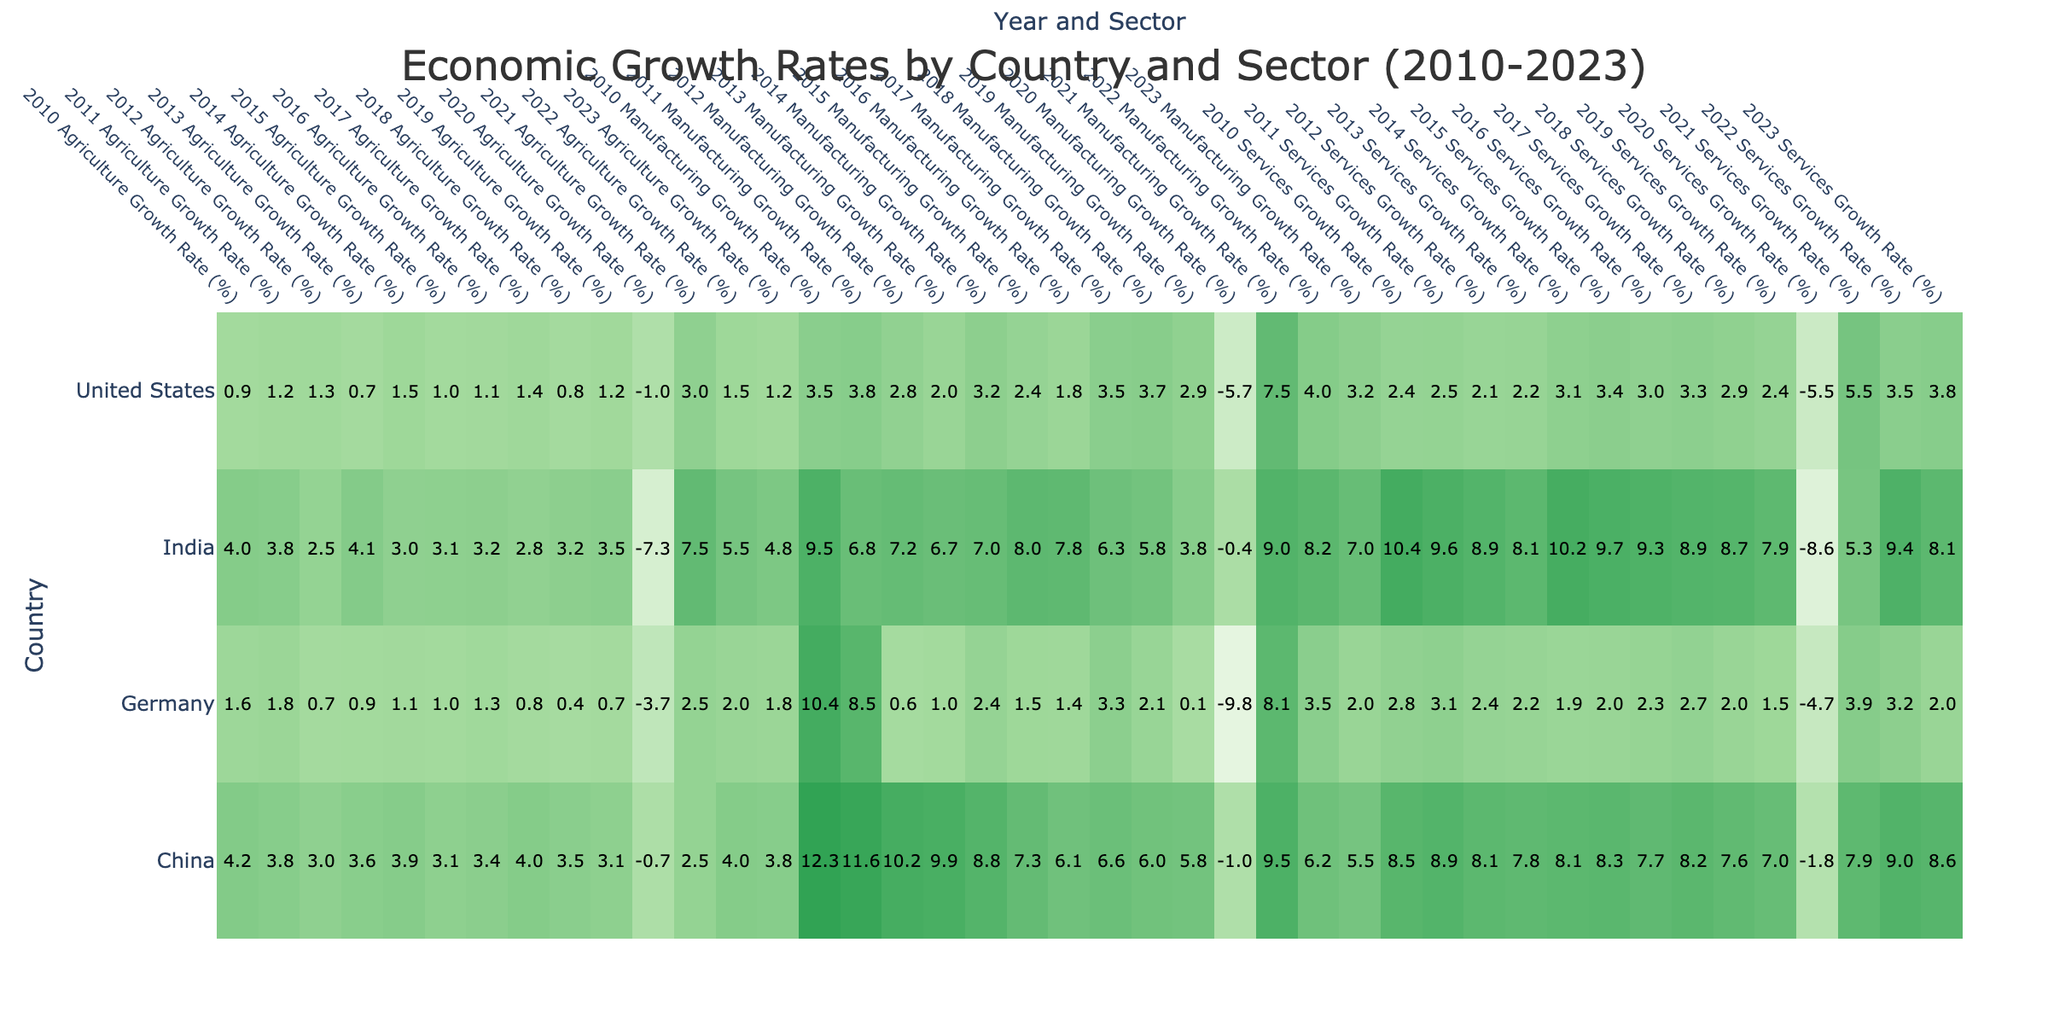What was the Agriculture Growth Rate of India in 2021? Referring to the table, we find that the Agriculture Growth Rate for India in 2021 is listed directly as 7.5%.
Answer: 7.5% What was the highest Manufacturing Growth Rate observed in Germany between 2010 and 2023? Looking through the Manufacturing Growth Rate data for Germany from 2010 to 2023, the highest rate is 10.4% in 2010.
Answer: 10.4% Was there a year where the Services Growth Rate for the United States was negative? In the table, we check the Services Growth Rate for the United States and find that in 2020, the rate was -5.5%, indicating there was indeed a year with a negative value.
Answer: Yes What was the average Services Growth Rate for China from 2010 to 2023? We need to sum up the Services Growth Rates for China from 2010 to 2023, which totals to 113.6% (the rates for each year are 8.5, 8.9, 8.1, 7.8, 8.1, 8.3, 7.7, 8.2, 7.6, 7.0, -1.8, 7.9, 9.0, 8.6). There are 14 entries, so the average growth rate is 113.6/14 = 8.1%.
Answer: 8.1% Which country had the largest decline in Agriculture Growth Rate in 2020 compared to 2019? By examining the Agriculture Growth Rates for 2019 and 2020, we find that India saw a drop from 3.5% in 2019 to -7.3% in 2020, which is a decline of 10.8 percentage points, the largest decline among the countries listed.
Answer: India What was the difference in the Manufacturing Growth Rates between the United States and Germany in 2021? The Manufacturing Growth Rate for the United States in 2021 is 7.5% while for Germany it is 8.1%. The difference is 8.1% - 7.5% = 0.6%.
Answer: 0.6% 